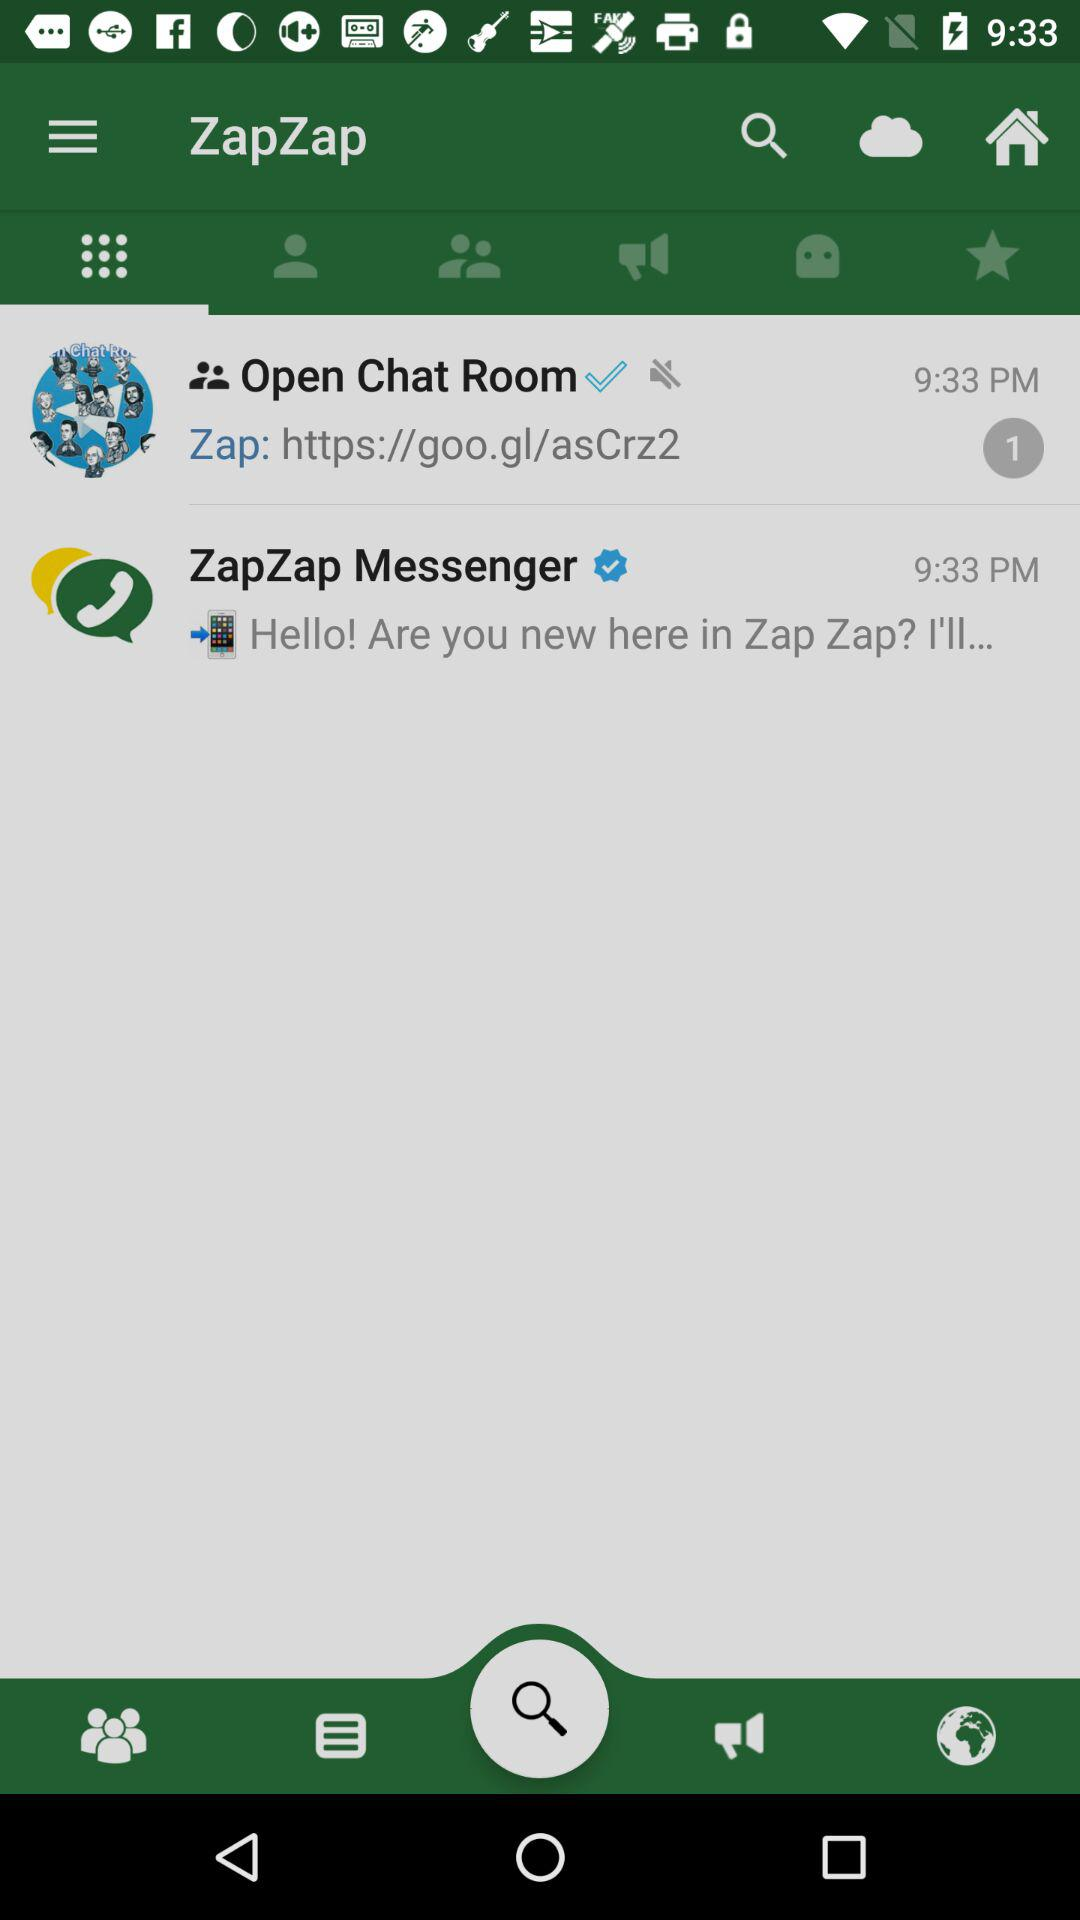What is the number of new messages in the "Open Chat Room"? The number of new messages in the "Open Chat Room" is 1. 